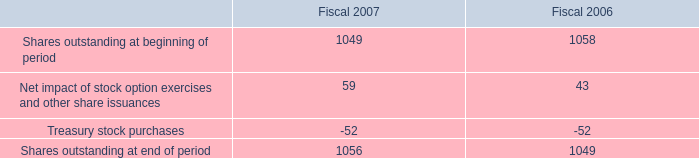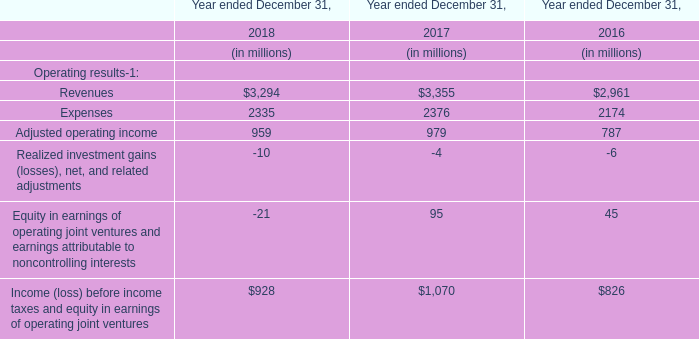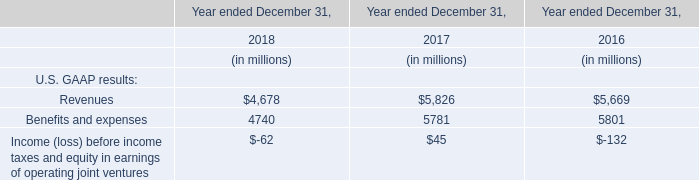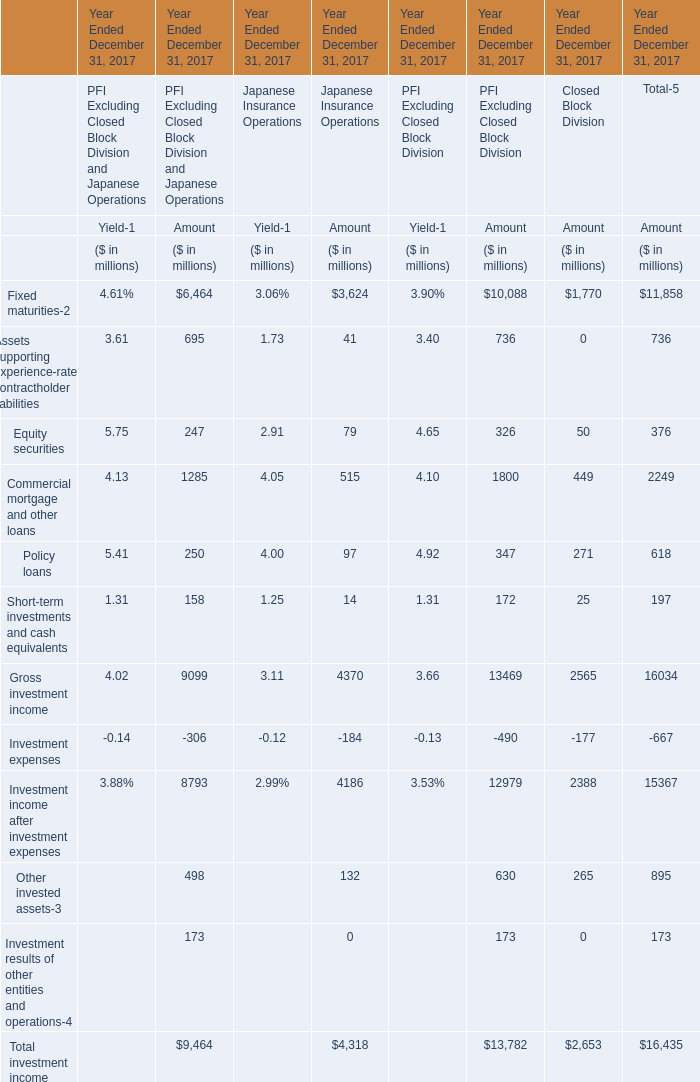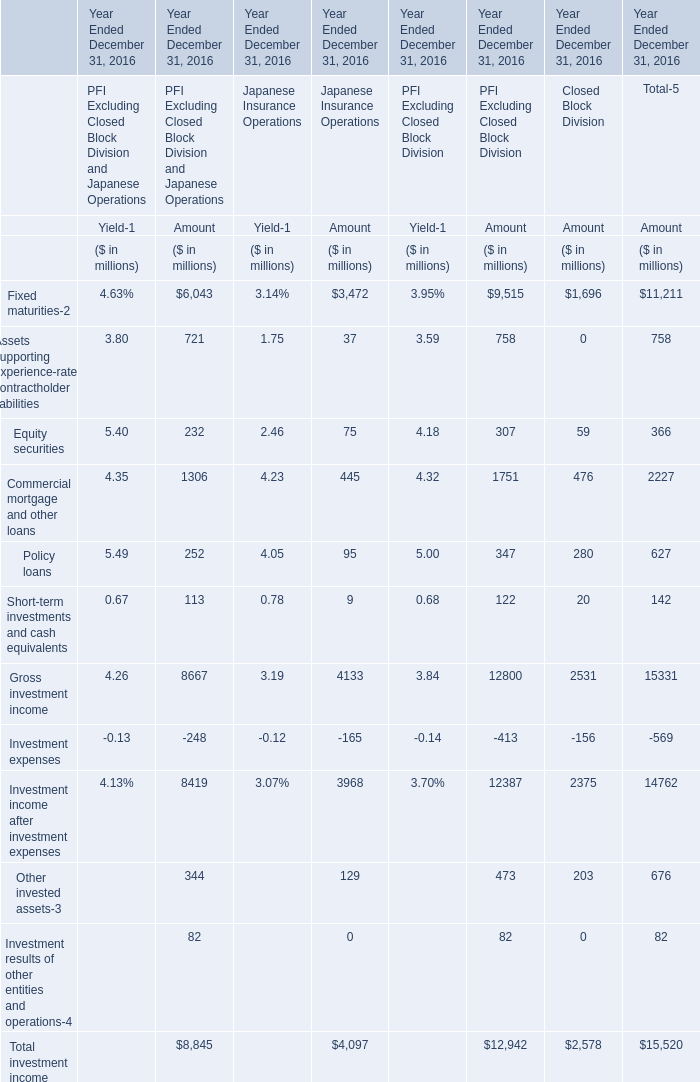In what sections is Assets supporting experience-rated contractholder liabilities positive? 
Answer: PFI Excluding Closed Block Division and Japanese Operations and Japanese Insurance OperationsPFI Excluding Closed Block DivisionTotal-5. 